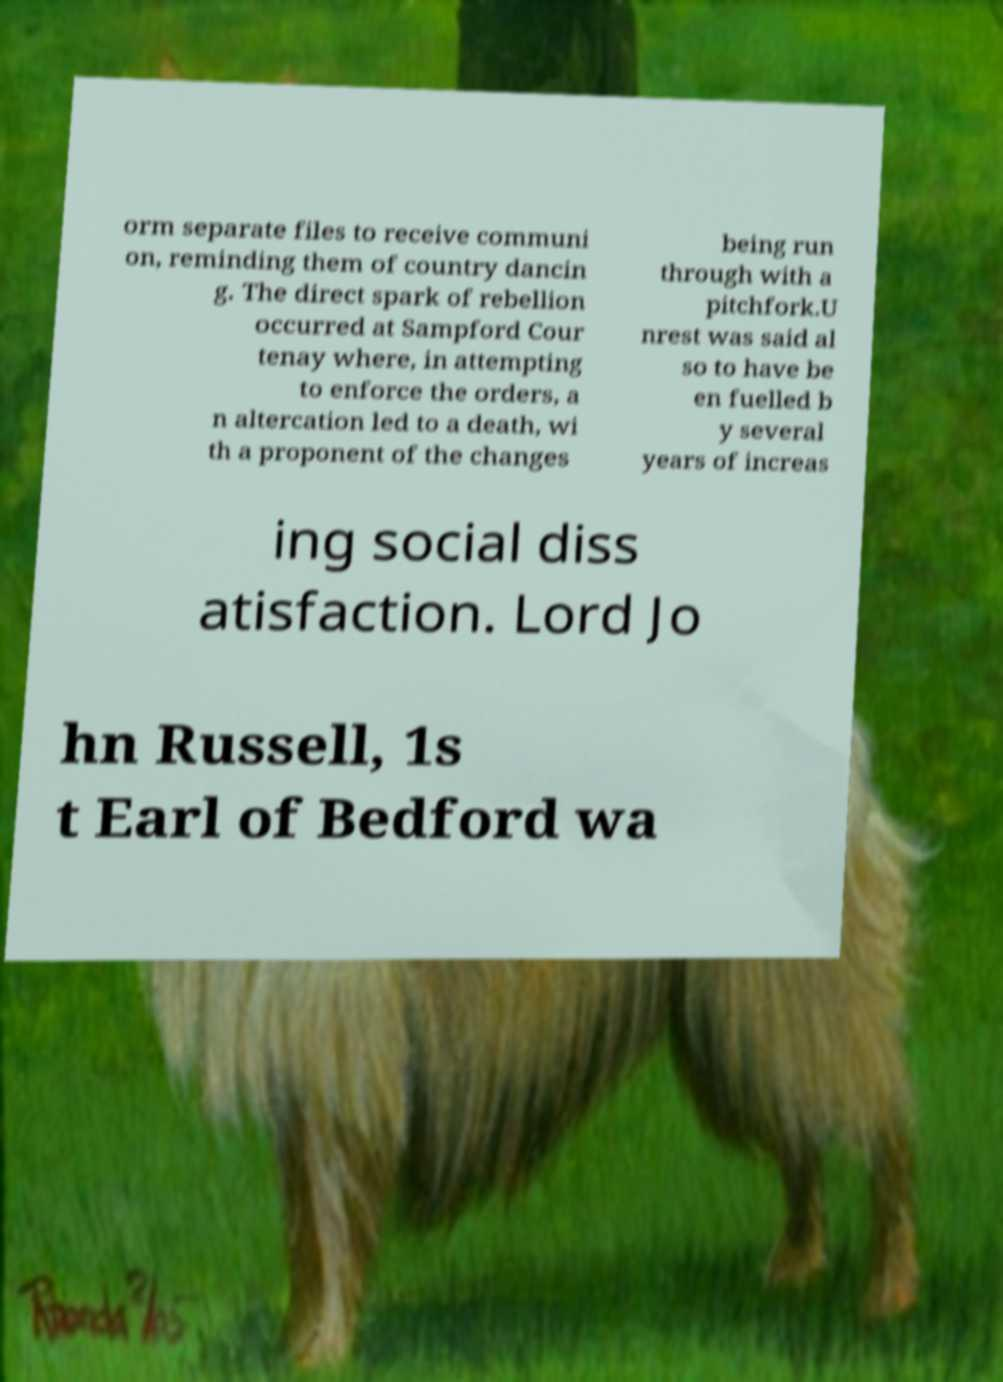Please read and relay the text visible in this image. What does it say? orm separate files to receive communi on, reminding them of country dancin g. The direct spark of rebellion occurred at Sampford Cour tenay where, in attempting to enforce the orders, a n altercation led to a death, wi th a proponent of the changes being run through with a pitchfork.U nrest was said al so to have be en fuelled b y several years of increas ing social diss atisfaction. Lord Jo hn Russell, 1s t Earl of Bedford wa 